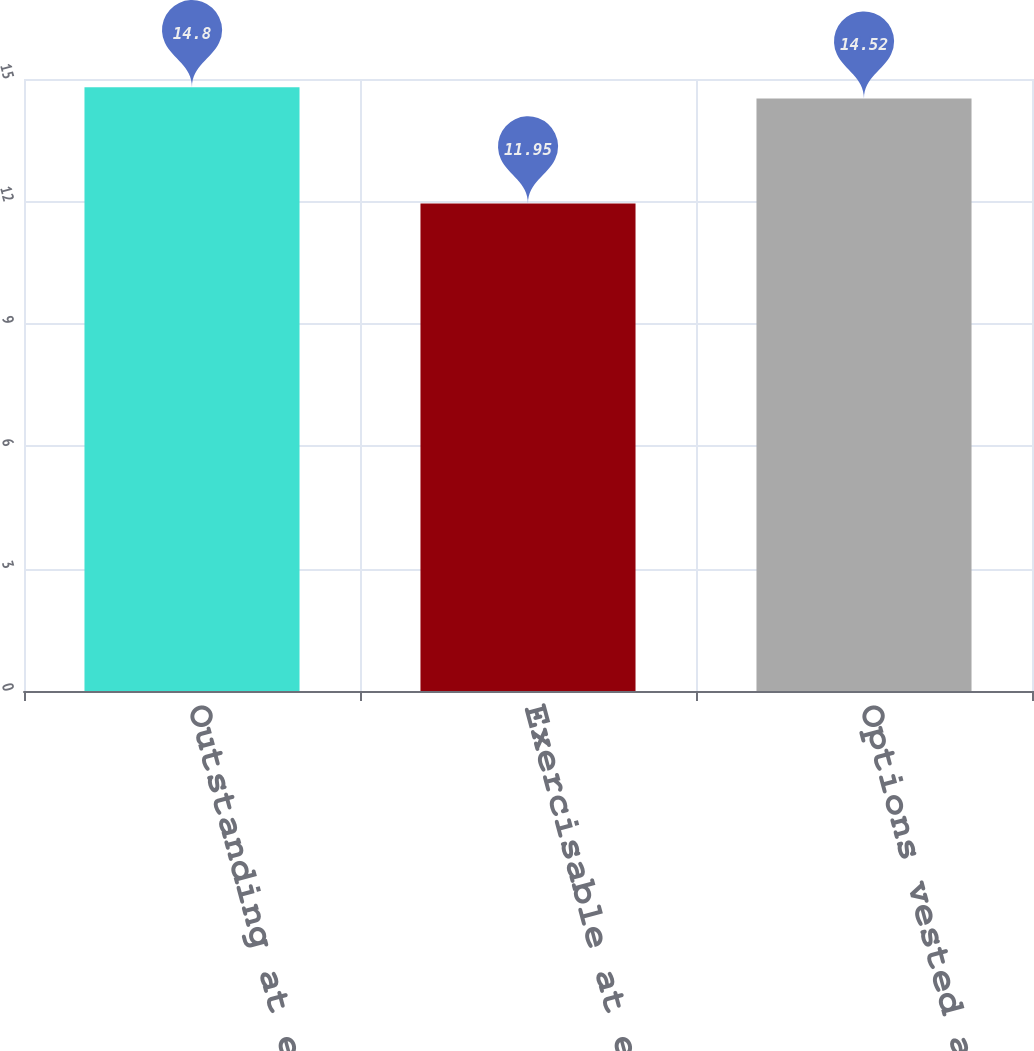Convert chart to OTSL. <chart><loc_0><loc_0><loc_500><loc_500><bar_chart><fcel>Outstanding at end of year<fcel>Exercisable at end of year<fcel>Options vested and expected to<nl><fcel>14.8<fcel>11.95<fcel>14.52<nl></chart> 